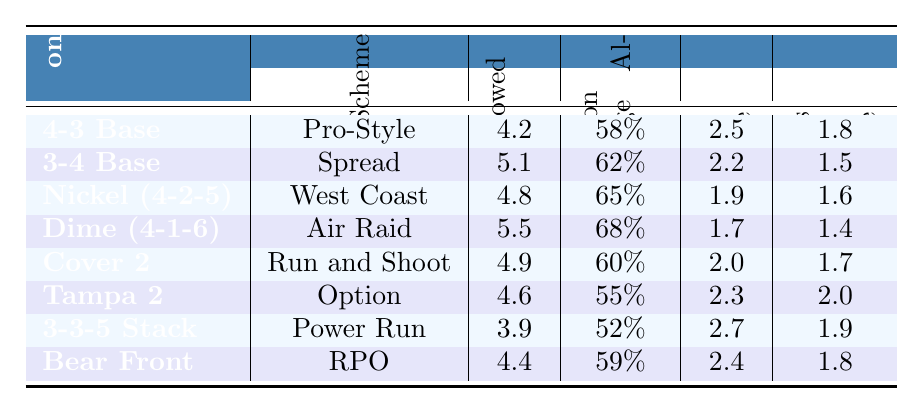What is the defensive formation that allows the fewest yards per play? The table lists the yards allowed per play for each defensive formation. The formation that allows the fewest yards per play is "3-3-5 Stack" at 3.9 yards.
Answer: 3-3-5 Stack Which offensive scheme is associated with the highest completion percentage allowed? The table shows the completion percentages allowed for different formations against various schemes. The highest completion percentage allowed is 68%, associated with the "Dime (4-1-6)" formation against the "Air Raid" scheme.
Answer: Dime (4-1-6) How many turnovers are forced per game by the "Tampa 2" formation? The table provides specific values for turnovers forced per game for each defensive formation. The "Tampa 2" formation forces 2.0 turnovers per game.
Answer: 2.0 What is the average number of sacks per game across all formations? To find the average, add up the sacks per game for all formations and divide by the number of formations. The total sacks are (2.5 + 2.2 + 1.9 + 1.7 + 2.0 + 2.3 + 2.7 + 2.4) = 16.7, and with 8 formations, the average is 16.7/8 = 2.09.
Answer: 2.09 Does the "Cover 2" formation force more turnovers than the "Dime (4-1-6)" formation? According to the table, "Cover 2" forces 1.7 turnovers per game while "Dime (4-1-6)" forces 1.4. Therefore, "Cover 2" does force more turnovers.
Answer: Yes Which defensive formation has a lower completion percentage allowed, "4-3 Base" or "Bear Front"? "4-3 Base" has a completion percentage allowed of 58%, while "Bear Front" has 59%. Therefore, "4-3 Base" has a lower completion percentage allowed.
Answer: 4-3 Base What is the difference in yards allowed per play between the "3-3-5 Stack" and "Nickel (4-2-5)" formations? The yards allowed per play for "3-3-5 Stack" is 3.9, and for "Nickel (4-2-5)" it is 4.8. The difference is 4.8 - 3.9 = 0.9 yards.
Answer: 0.9 yards Which formation shows the best performance in terms of both sacks and turnovers forced? Review the sacks per game and turnovers forced per game for each formation. The "3-3-5 Stack" has the most sacks at 2.7 and 1.9 turnovers. The "Tampa 2" shows 2.3 sacks and 2.0 turnovers. Collectively, "3-3-5 Stack" yields better output in sacks but "Tampa 2" in turnovers. Assessing both metrics, we see no single formation dominates.
Answer: No single formation Is the "Air Raid" offensive scheme less effective against the "Dime (4-1-6)" defense compared to the "Pro-Style" scheme against the "4-3 Base"? For "Air Raid" against "Dime (4-1-6)", the yards allowed is 5.5, completion percentage 68%, sacks 1.7, turnovers 1.4. For "Pro-Style" against "4-3 Base", the yards allowed is 4.2, completion percentage 58%, sacks 2.5, turnovers 1.8. Overall, "Dime" allows more yards and has poorer performance metrics, confirming its less effectiveness.
Answer: Yes If we list formations in order of yards allowed per play from least to most, what is the second formation on that list? The formation with the least yards allowed is "3-3-5 Stack" (3.9), followed by "4-3 Base" (4.2) as the second formation when listed.
Answer: 4-3 Base 